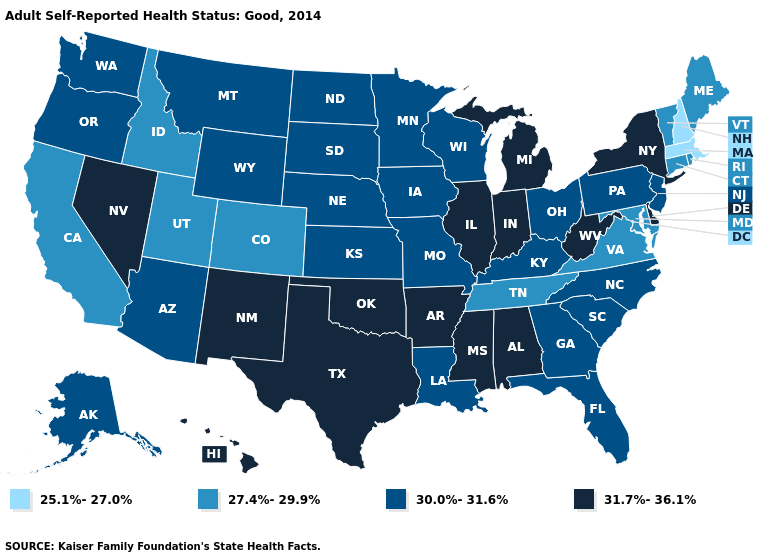What is the value of Hawaii?
Answer briefly. 31.7%-36.1%. What is the highest value in the USA?
Write a very short answer. 31.7%-36.1%. Does Maryland have a lower value than Delaware?
Be succinct. Yes. Name the states that have a value in the range 31.7%-36.1%?
Keep it brief. Alabama, Arkansas, Delaware, Hawaii, Illinois, Indiana, Michigan, Mississippi, Nevada, New Mexico, New York, Oklahoma, Texas, West Virginia. Which states have the lowest value in the USA?
Answer briefly. Massachusetts, New Hampshire. What is the value of South Dakota?
Keep it brief. 30.0%-31.6%. What is the value of Maine?
Be succinct. 27.4%-29.9%. Does Missouri have the same value as West Virginia?
Concise answer only. No. Which states hav the highest value in the South?
Concise answer only. Alabama, Arkansas, Delaware, Mississippi, Oklahoma, Texas, West Virginia. What is the value of Arkansas?
Keep it brief. 31.7%-36.1%. What is the value of New Jersey?
Keep it brief. 30.0%-31.6%. Which states have the highest value in the USA?
Be succinct. Alabama, Arkansas, Delaware, Hawaii, Illinois, Indiana, Michigan, Mississippi, Nevada, New Mexico, New York, Oklahoma, Texas, West Virginia. Which states have the lowest value in the West?
Write a very short answer. California, Colorado, Idaho, Utah. How many symbols are there in the legend?
Concise answer only. 4. Is the legend a continuous bar?
Write a very short answer. No. 